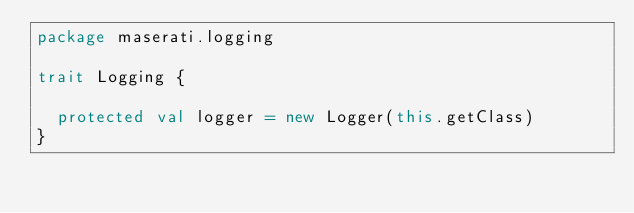<code> <loc_0><loc_0><loc_500><loc_500><_Scala_>package maserati.logging

trait Logging {
  
  protected val logger = new Logger(this.getClass)
}
</code> 